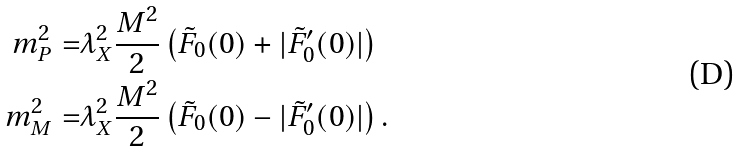Convert formula to latex. <formula><loc_0><loc_0><loc_500><loc_500>m _ { P } ^ { 2 } = & \lambda _ { X } ^ { 2 } \frac { M ^ { 2 } } { 2 } \left ( \tilde { F } _ { 0 } ( 0 ) + | \tilde { F } _ { 0 } ^ { \prime } ( 0 ) | \right ) \\ m _ { M } ^ { 2 } = & \lambda _ { X } ^ { 2 } \frac { M ^ { 2 } } { 2 } \left ( \tilde { F } _ { 0 } ( 0 ) - | \tilde { F } _ { 0 } ^ { \prime } ( 0 ) | \right ) .</formula> 